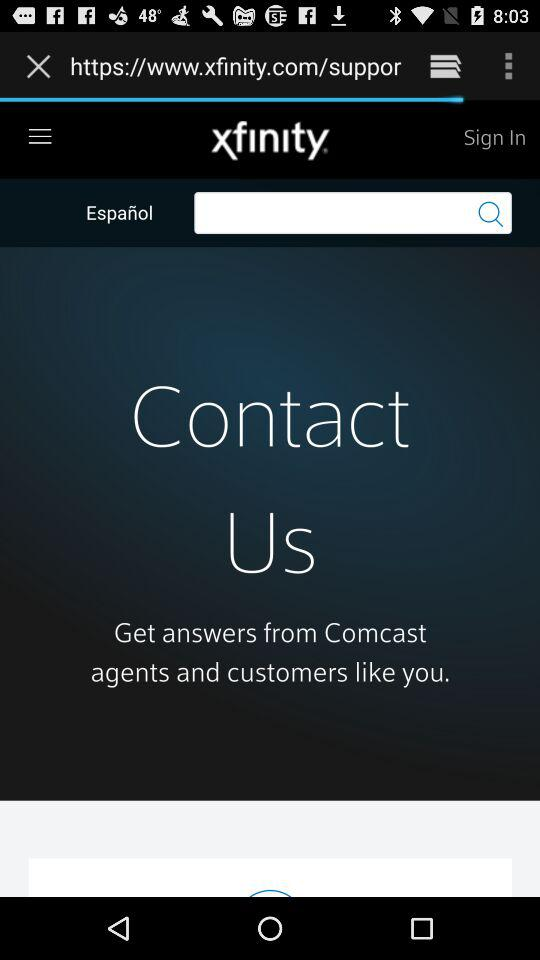What are the sign-in requirements?
When the provided information is insufficient, respond with <no answer>. <no answer> 